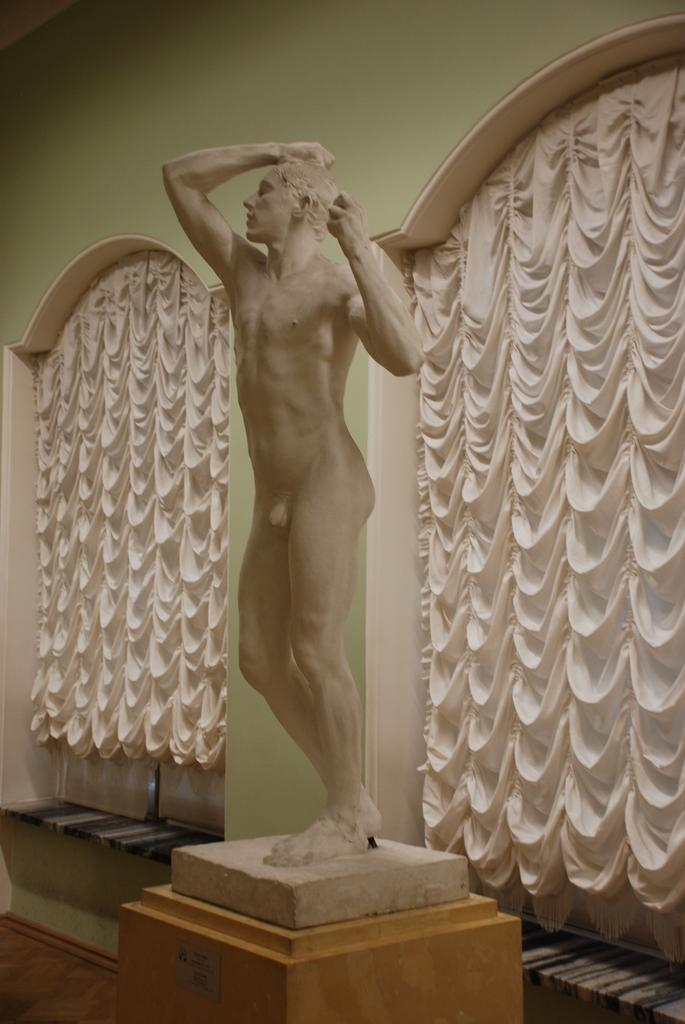What is the main subject of the image? There is a statue of a person on a platform in the image. What can be seen in the background of the image? There is a wall and curtains in the background of the image. What type of wine is being served by the fairies in the image? There are no fairies or wine present in the image; it features a statue of a person on a platform and a background with a wall and curtains. 